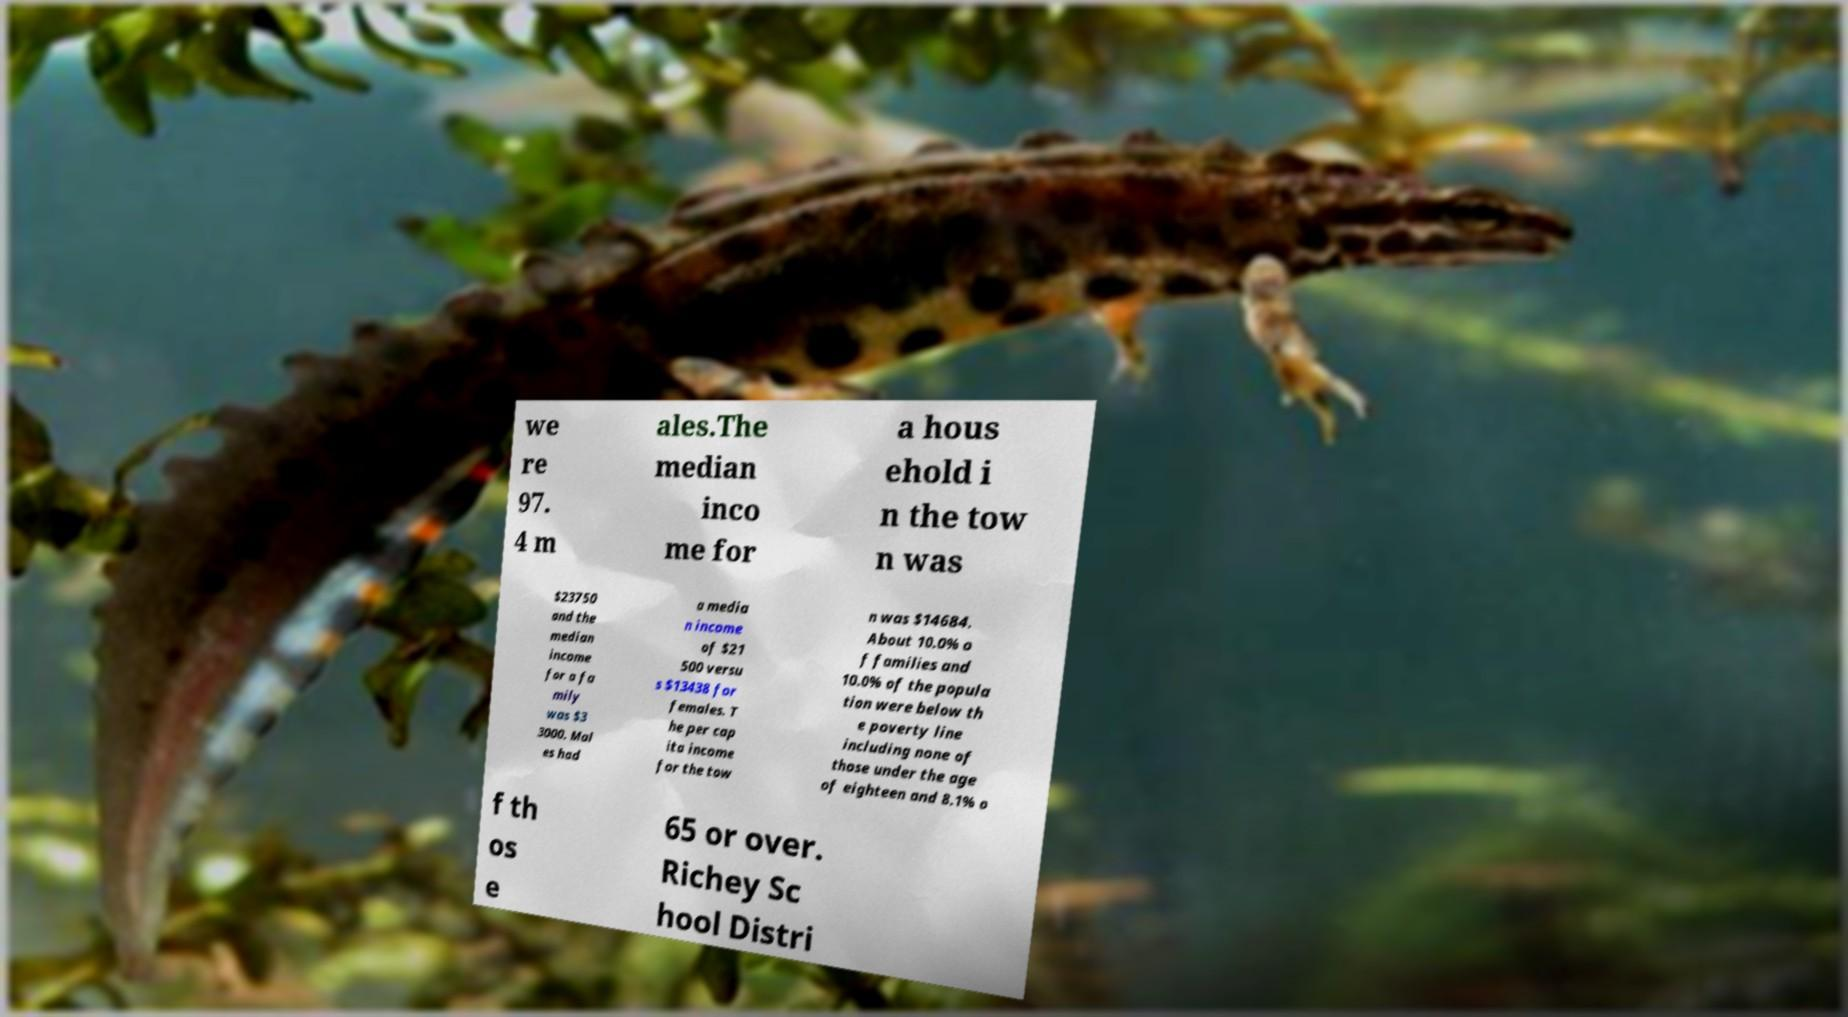Please identify and transcribe the text found in this image. we re 97. 4 m ales.The median inco me for a hous ehold i n the tow n was $23750 and the median income for a fa mily was $3 3000. Mal es had a media n income of $21 500 versu s $13438 for females. T he per cap ita income for the tow n was $14684. About 10.0% o f families and 10.0% of the popula tion were below th e poverty line including none of those under the age of eighteen and 8.1% o f th os e 65 or over. Richey Sc hool Distri 